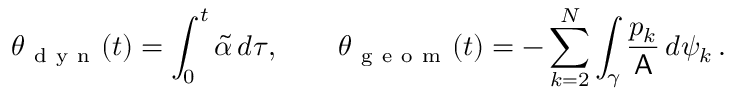<formula> <loc_0><loc_0><loc_500><loc_500>\theta _ { d y n } ( t ) = \int _ { 0 } ^ { t } \widetilde { \alpha } \, d \tau , \quad \theta _ { g e o m } ( t ) = - \sum _ { k = 2 } ^ { N } \int _ { \gamma } \frac { p _ { k } } { A } \, d \psi _ { k } \, .</formula> 